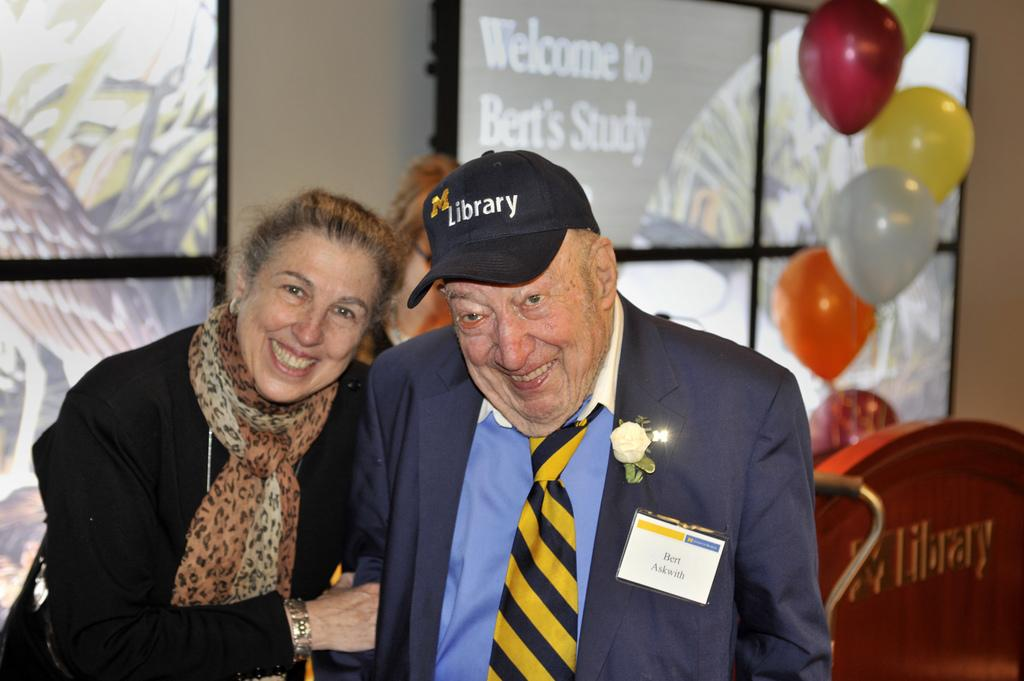How many people are in the image? There are two people in the image. What is the facial expression of the people in the image? The people are smiling. What can be seen in the background of the image? There is a wall, windows, balloons, and an object in the background of the image. What type of pie is the father holding in the image? There is no father or pie present in the image. What thought is going through the minds of the people in the image? We cannot determine the thoughts of the people in the image based on the provided facts. 